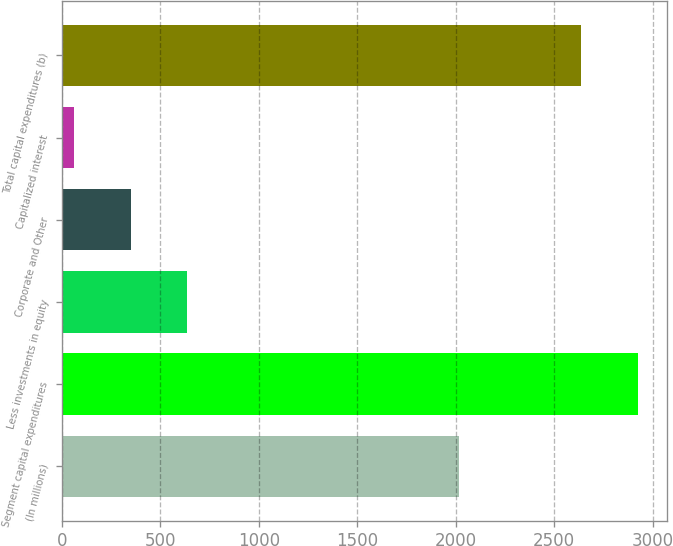<chart> <loc_0><loc_0><loc_500><loc_500><bar_chart><fcel>(In millions)<fcel>Segment capital expenditures<fcel>Less investments in equity<fcel>Corporate and Other<fcel>Capitalized interest<fcel>Total capital expenditures (b)<nl><fcel>2016<fcel>2925<fcel>635.4<fcel>349.2<fcel>63<fcel>2638<nl></chart> 